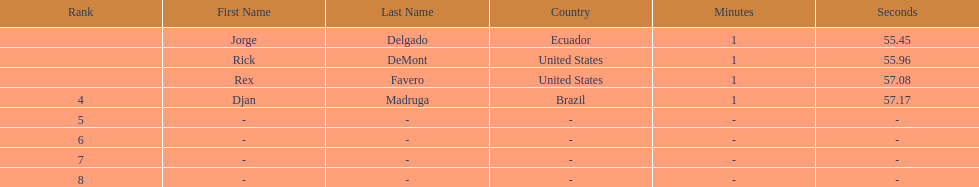Who finished with the top time? Jorge Delgado. 